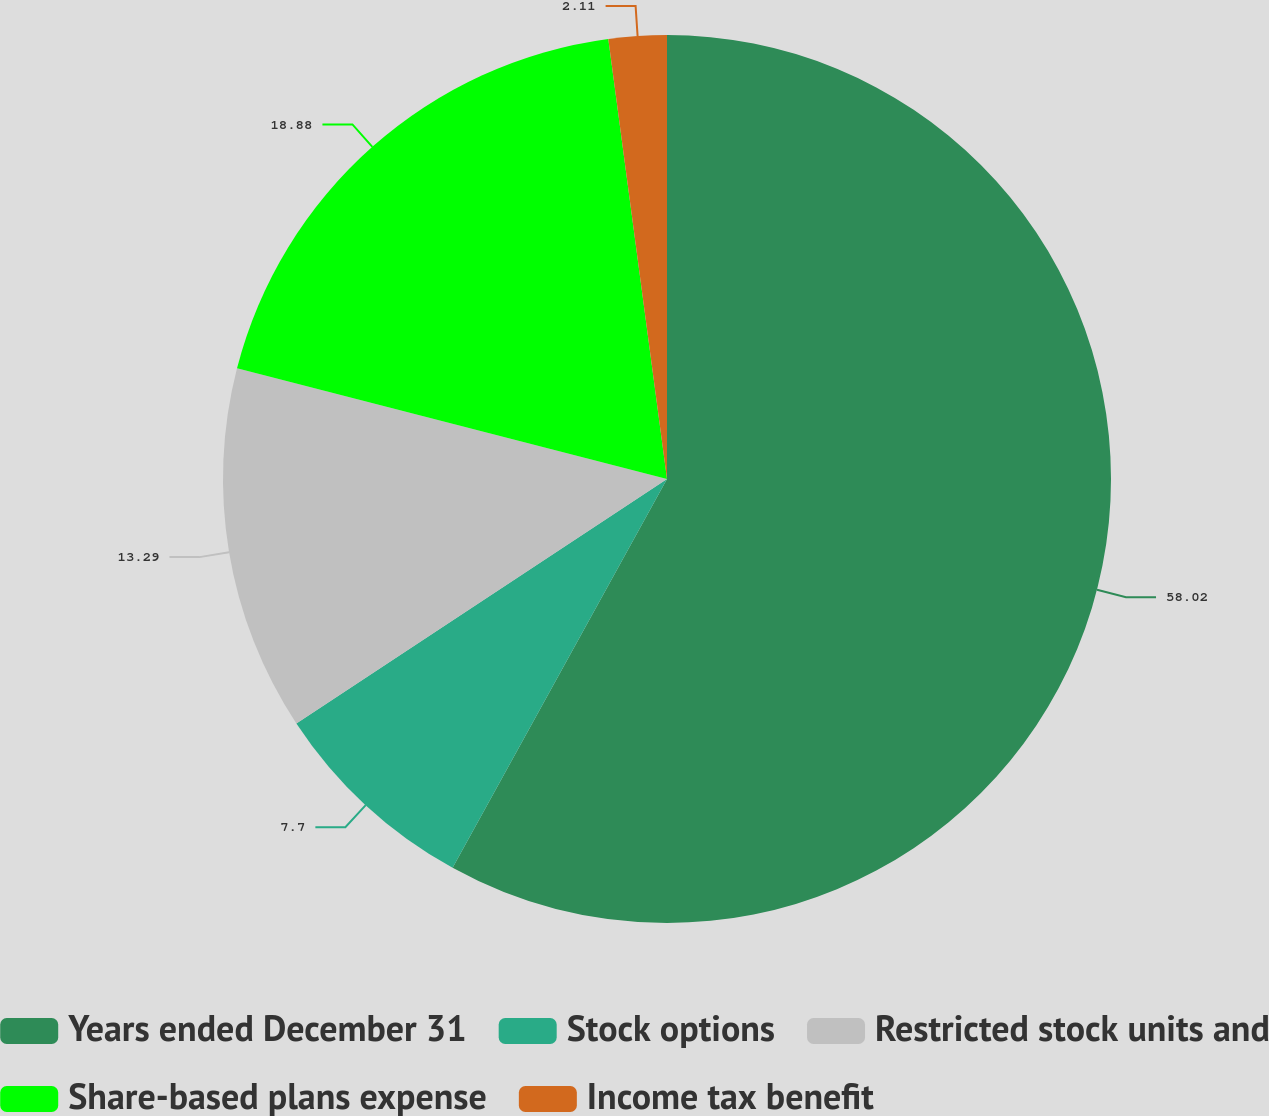Convert chart. <chart><loc_0><loc_0><loc_500><loc_500><pie_chart><fcel>Years ended December 31<fcel>Stock options<fcel>Restricted stock units and<fcel>Share-based plans expense<fcel>Income tax benefit<nl><fcel>58.02%<fcel>7.7%<fcel>13.29%<fcel>18.88%<fcel>2.11%<nl></chart> 